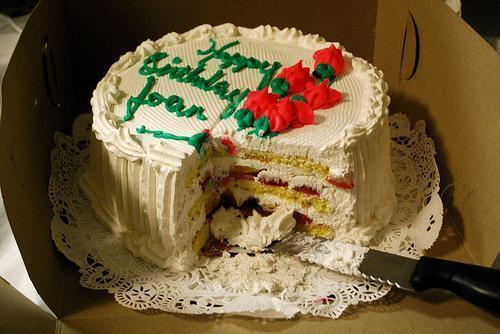How many layers is the cake?
Give a very brief answer. 3. 